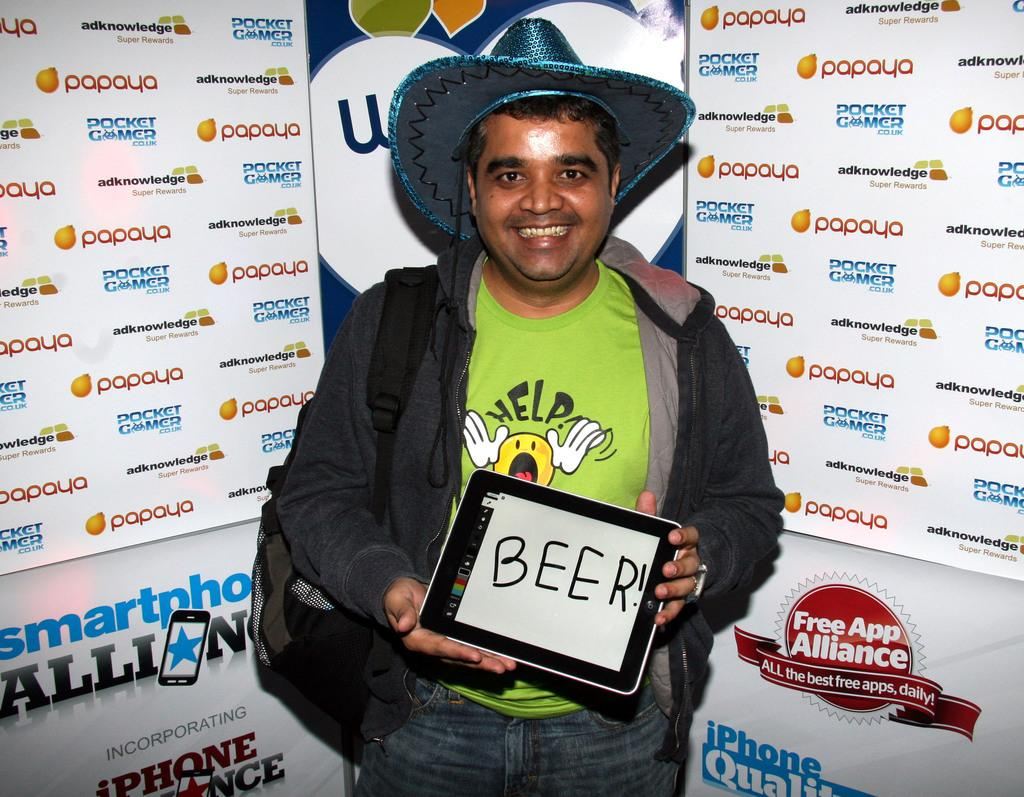Who is present in the image? There is a man in the image. What is the man wearing on his head? The man is wearing a hat. What is the man holding in his hand? The man is holding a tab. What can be seen in the background of the image? There is a hoarding in the background of the image. What type of discussion is taking place between the man and the note in the image? There is no note present in the image, and therefore no discussion can be observed. 